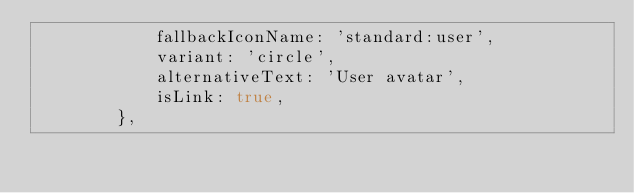<code> <loc_0><loc_0><loc_500><loc_500><_JavaScript_>            fallbackIconName: 'standard:user',
            variant: 'circle',
            alternativeText: 'User avatar',
            isLink: true,
        },</code> 